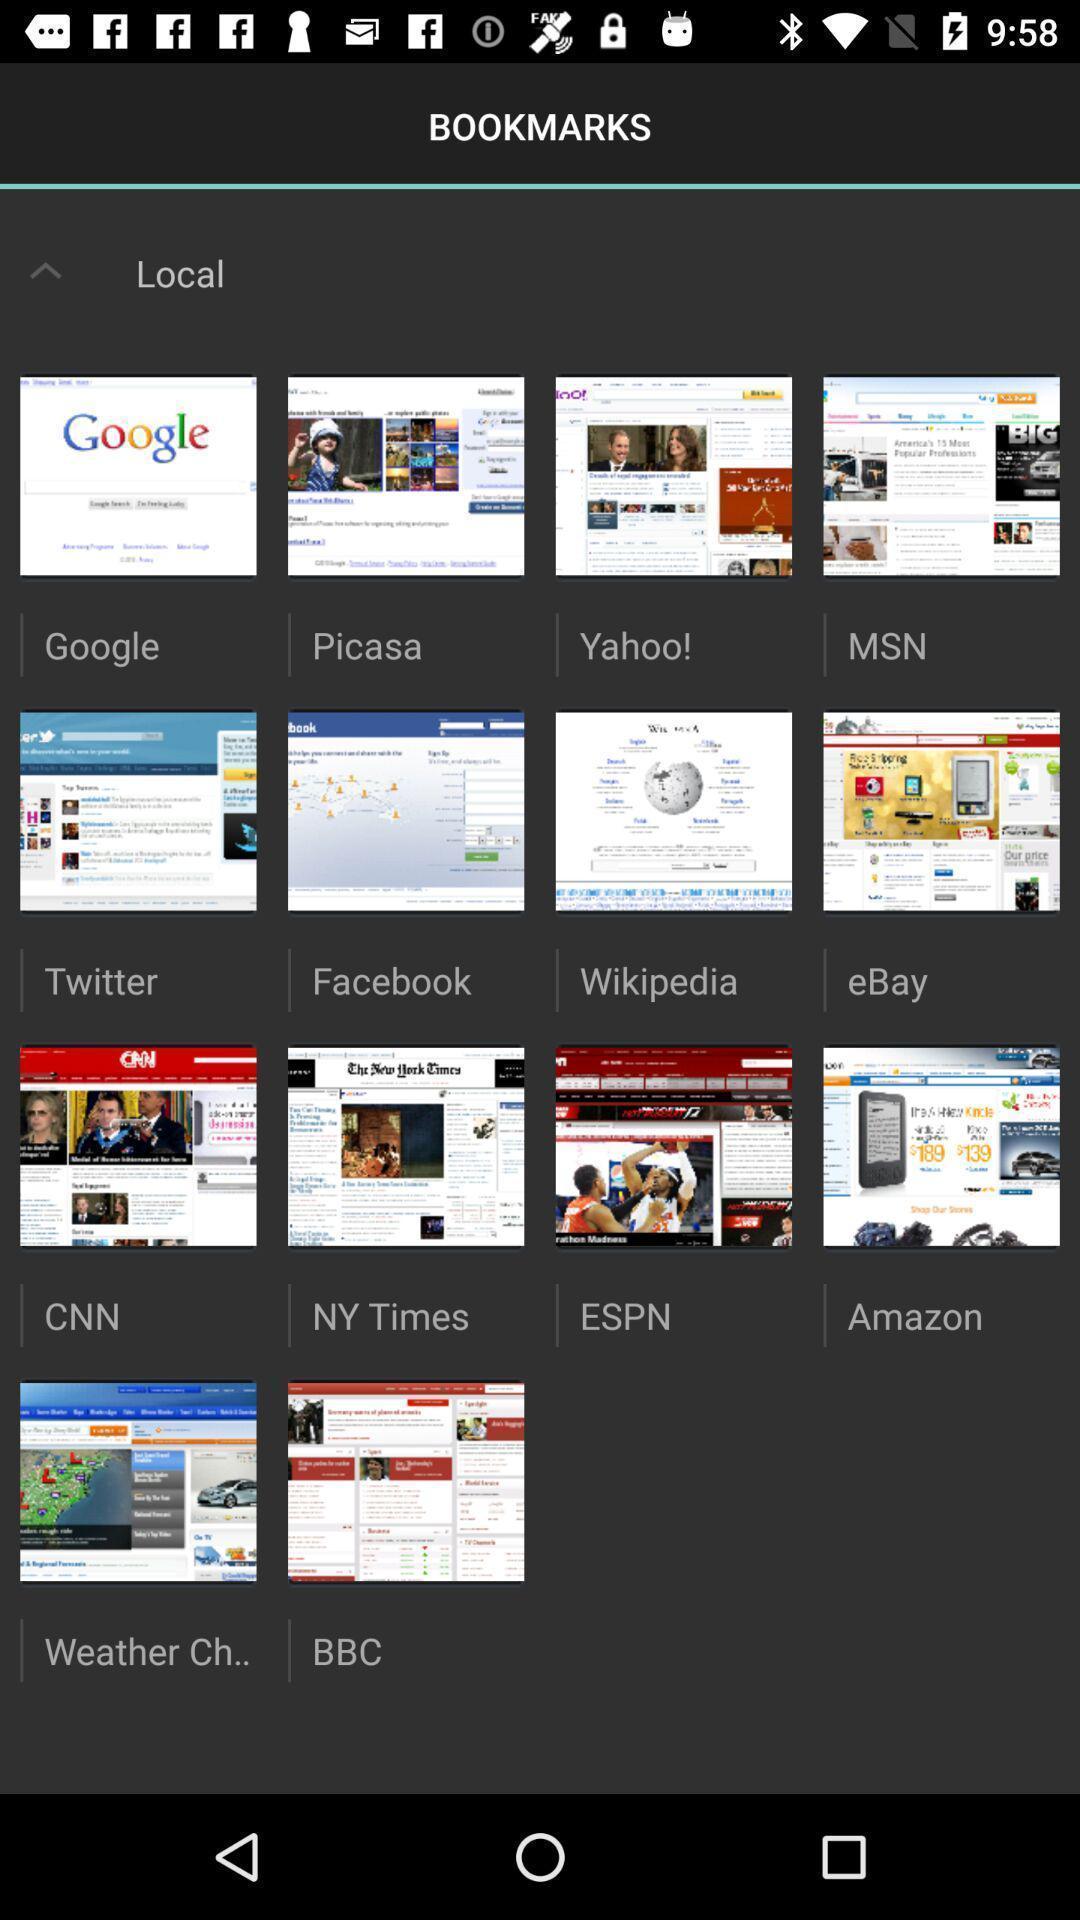Explain the elements present in this screenshot. Screen page displaying various applications. 